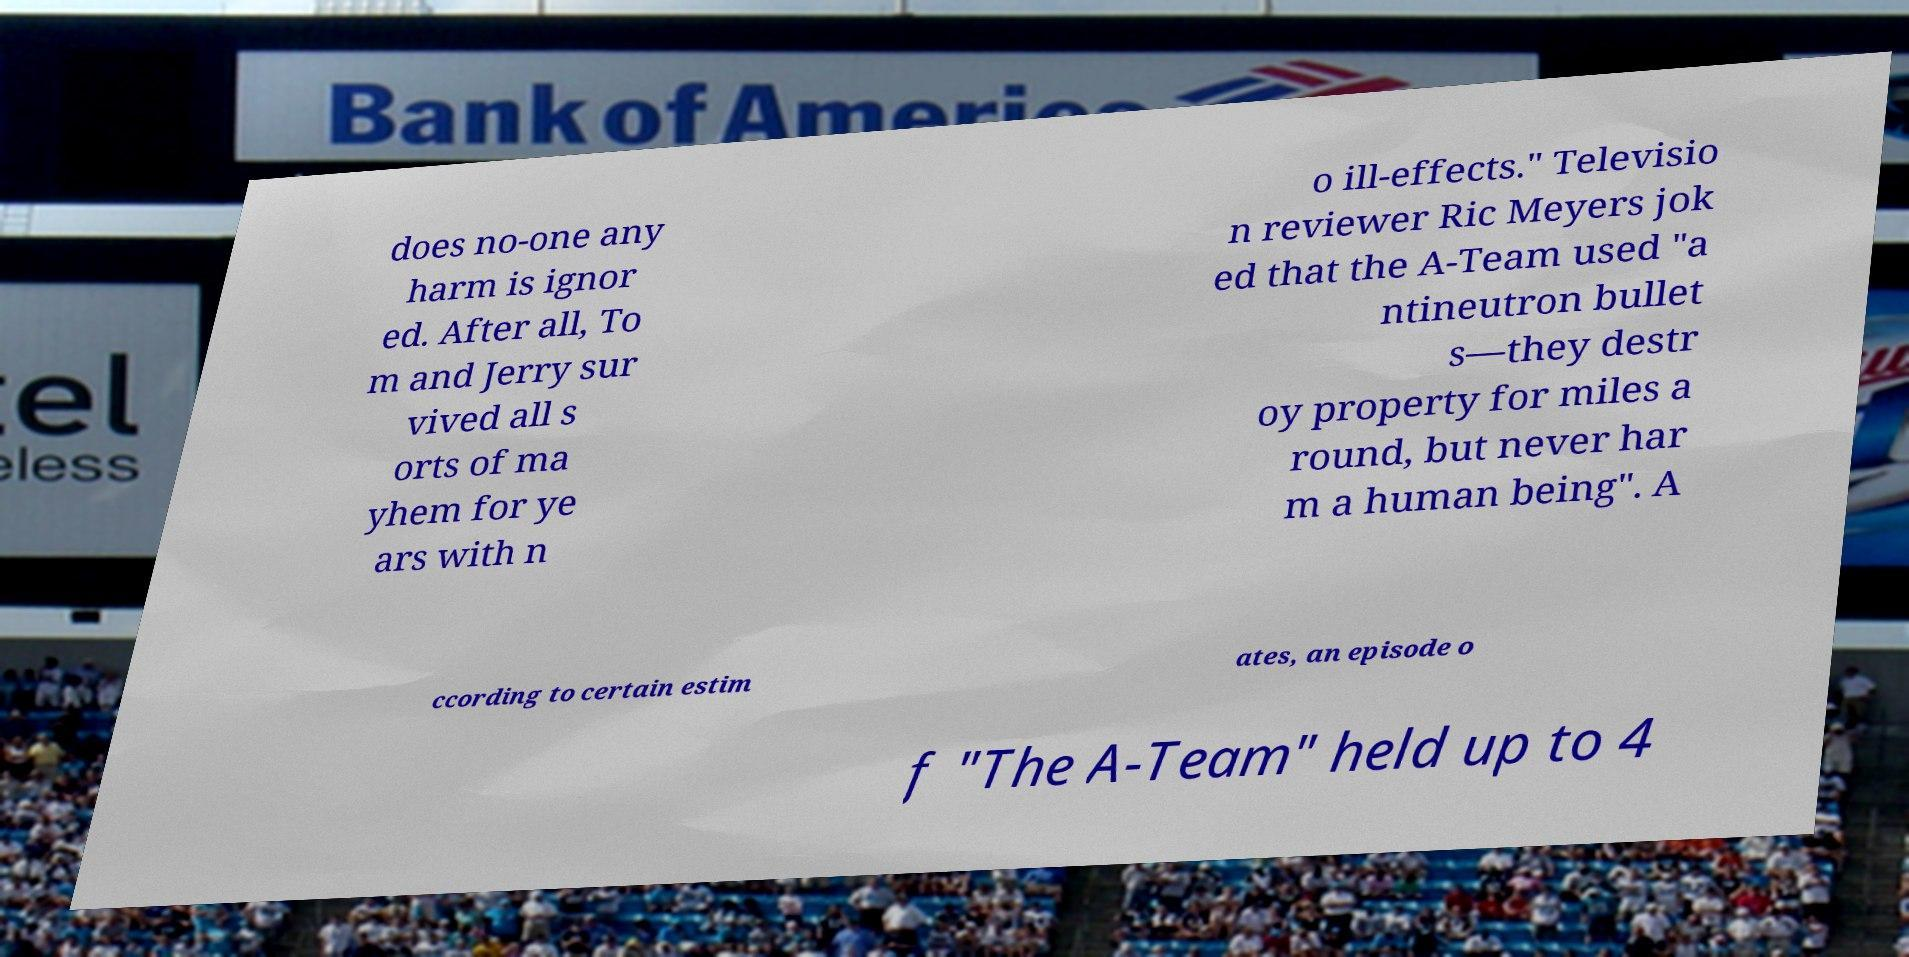Can you read and provide the text displayed in the image?This photo seems to have some interesting text. Can you extract and type it out for me? does no-one any harm is ignor ed. After all, To m and Jerry sur vived all s orts of ma yhem for ye ars with n o ill-effects." Televisio n reviewer Ric Meyers jok ed that the A-Team used "a ntineutron bullet s—they destr oy property for miles a round, but never har m a human being". A ccording to certain estim ates, an episode o f "The A-Team" held up to 4 